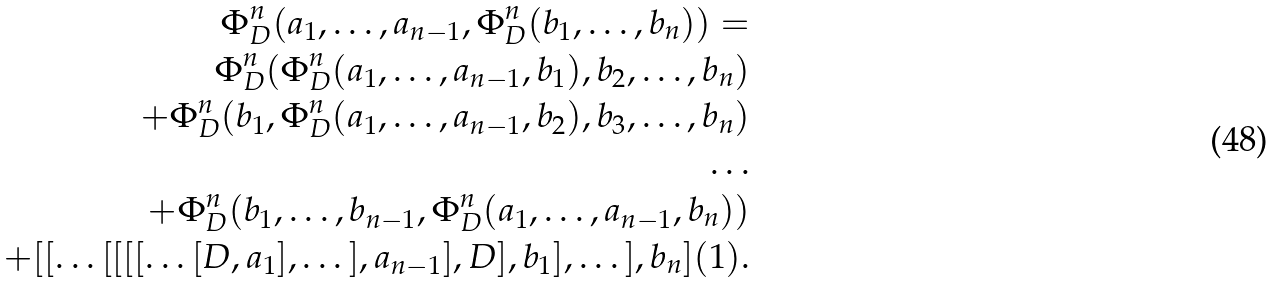Convert formula to latex. <formula><loc_0><loc_0><loc_500><loc_500>\Phi _ { D } ^ { n } ( a _ { 1 } , \dots , a _ { n - 1 } , \Phi _ { D } ^ { n } ( b _ { 1 } , \dots , b _ { n } ) ) = \\ \Phi _ { D } ^ { n } ( \Phi _ { D } ^ { n } ( a _ { 1 } , \dots , a _ { n - 1 } , b _ { 1 } ) , b _ { 2 } , \dots , b _ { n } ) \\ + \Phi _ { D } ^ { n } ( b _ { 1 } , \Phi _ { D } ^ { n } ( a _ { 1 } , \dots , a _ { n - 1 } , b _ { 2 } ) , b _ { 3 } , \dots , b _ { n } ) \\ \dots \\ + \Phi _ { D } ^ { n } ( b _ { 1 } , \dots , b _ { n - 1 } , \Phi _ { D } ^ { n } ( a _ { 1 } , \dots , a _ { n - 1 } , b _ { n } ) ) \\ + [ [ \dots [ [ [ [ \dots [ D , a _ { 1 } ] , \dots ] , a _ { n - 1 } ] , D ] , b _ { 1 } ] , \dots ] , b _ { n } ] ( 1 ) .</formula> 